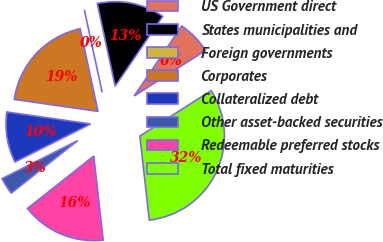Convert chart to OTSL. <chart><loc_0><loc_0><loc_500><loc_500><pie_chart><fcel>US Government direct<fcel>States municipalities and<fcel>Foreign governments<fcel>Corporates<fcel>Collateralized debt<fcel>Other asset-backed securities<fcel>Redeemable preferred stocks<fcel>Total fixed maturities<nl><fcel>6.45%<fcel>12.9%<fcel>0.0%<fcel>19.35%<fcel>9.68%<fcel>3.23%<fcel>16.13%<fcel>32.26%<nl></chart> 